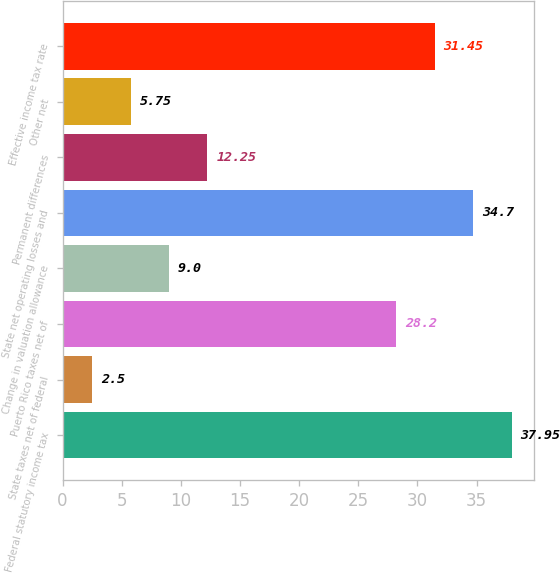<chart> <loc_0><loc_0><loc_500><loc_500><bar_chart><fcel>Federal statutory income tax<fcel>State taxes net of federal<fcel>Puerto Rico taxes net of<fcel>Change in valuation allowance<fcel>State net operating losses and<fcel>Permanent differences<fcel>Other net<fcel>Effective income tax rate<nl><fcel>37.95<fcel>2.5<fcel>28.2<fcel>9<fcel>34.7<fcel>12.25<fcel>5.75<fcel>31.45<nl></chart> 